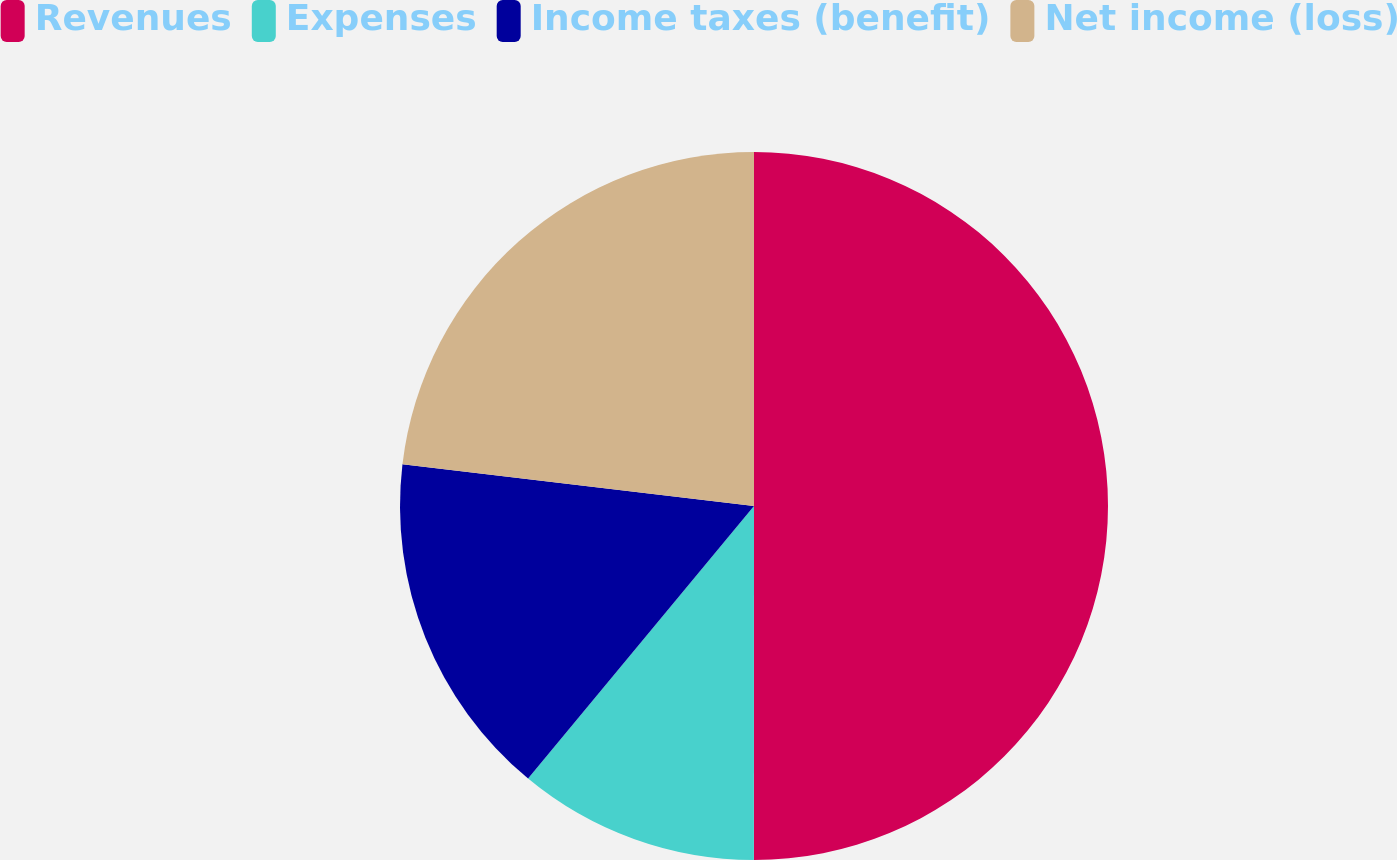Convert chart to OTSL. <chart><loc_0><loc_0><loc_500><loc_500><pie_chart><fcel>Revenues<fcel>Expenses<fcel>Income taxes (benefit)<fcel>Net income (loss)<nl><fcel>50.0%<fcel>11.01%<fcel>15.86%<fcel>23.12%<nl></chart> 